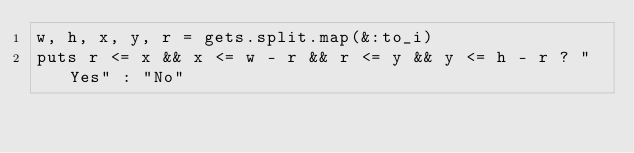Convert code to text. <code><loc_0><loc_0><loc_500><loc_500><_Ruby_>w, h, x, y, r = gets.split.map(&:to_i)
puts r <= x && x <= w - r && r <= y && y <= h - r ? "Yes" : "No"</code> 